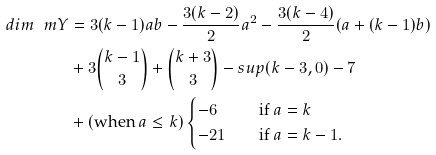Convert formula to latex. <formula><loc_0><loc_0><loc_500><loc_500>d i m \ m Y & = 3 ( k - 1 ) a b - \frac { 3 ( k - 2 ) } { 2 } a ^ { 2 } - \frac { 3 ( k - 4 ) } { 2 } ( a + ( k - 1 ) b ) \\ \quad & + 3 \binom { k - 1 } { 3 } + \binom { k + 3 } { 3 } - s u p ( k - 3 , 0 ) - 7 \\ \quad & + ( \text {when } a \leq k ) \begin{cases} - 6 \quad & \text {if } a = k \\ - 2 1 \quad & \text {if } a = k - 1 . \end{cases}</formula> 